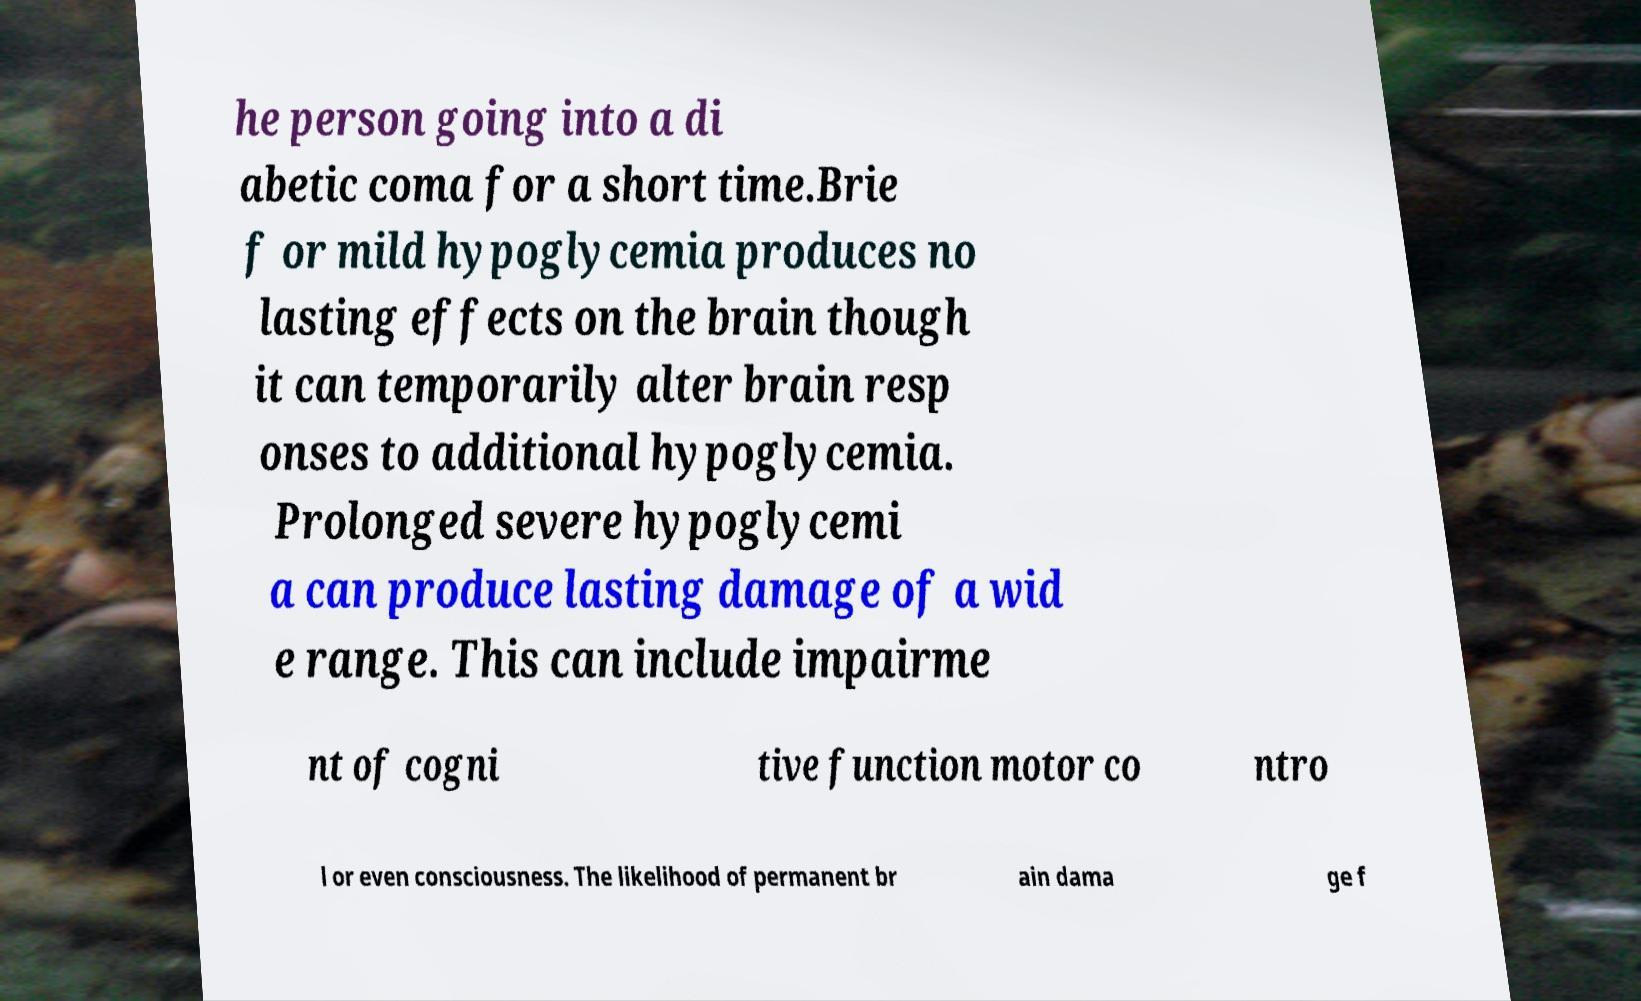For documentation purposes, I need the text within this image transcribed. Could you provide that? he person going into a di abetic coma for a short time.Brie f or mild hypoglycemia produces no lasting effects on the brain though it can temporarily alter brain resp onses to additional hypoglycemia. Prolonged severe hypoglycemi a can produce lasting damage of a wid e range. This can include impairme nt of cogni tive function motor co ntro l or even consciousness. The likelihood of permanent br ain dama ge f 